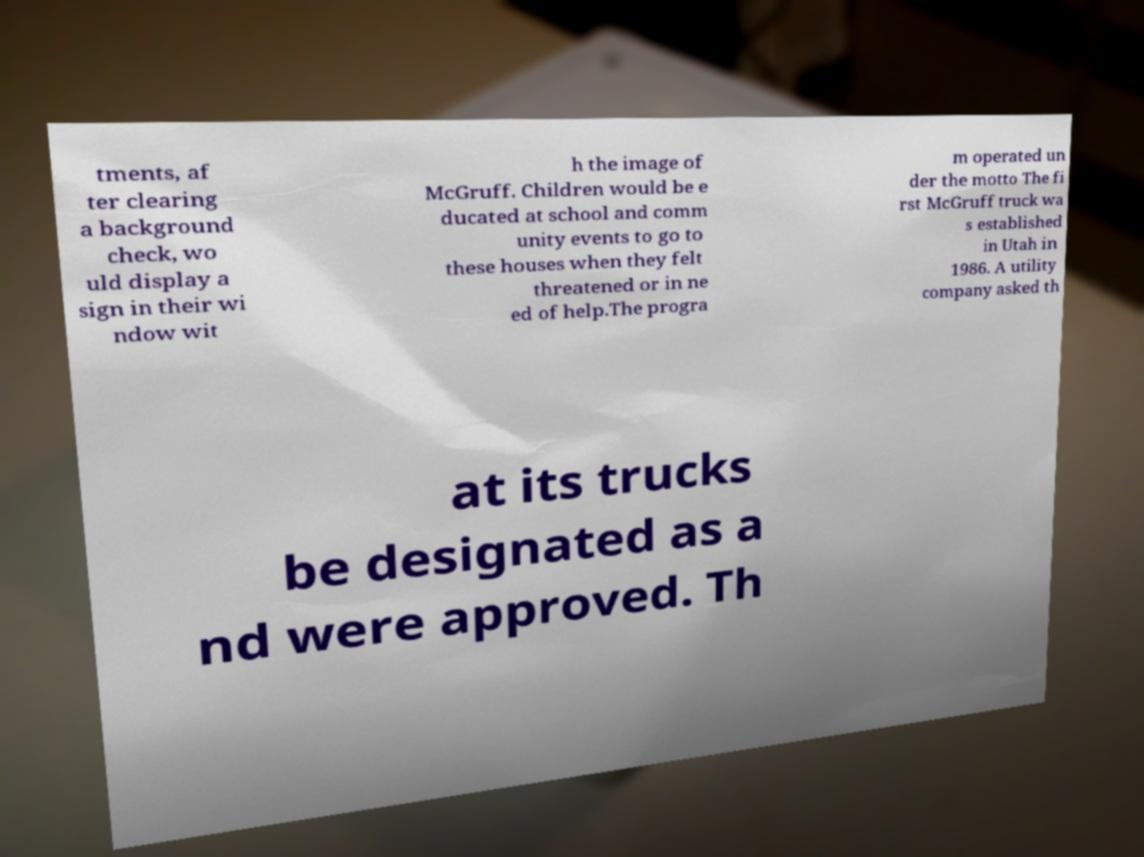For documentation purposes, I need the text within this image transcribed. Could you provide that? tments, af ter clearing a background check, wo uld display a sign in their wi ndow wit h the image of McGruff. Children would be e ducated at school and comm unity events to go to these houses when they felt threatened or in ne ed of help.The progra m operated un der the motto The fi rst McGruff truck wa s established in Utah in 1986. A utility company asked th at its trucks be designated as a nd were approved. Th 